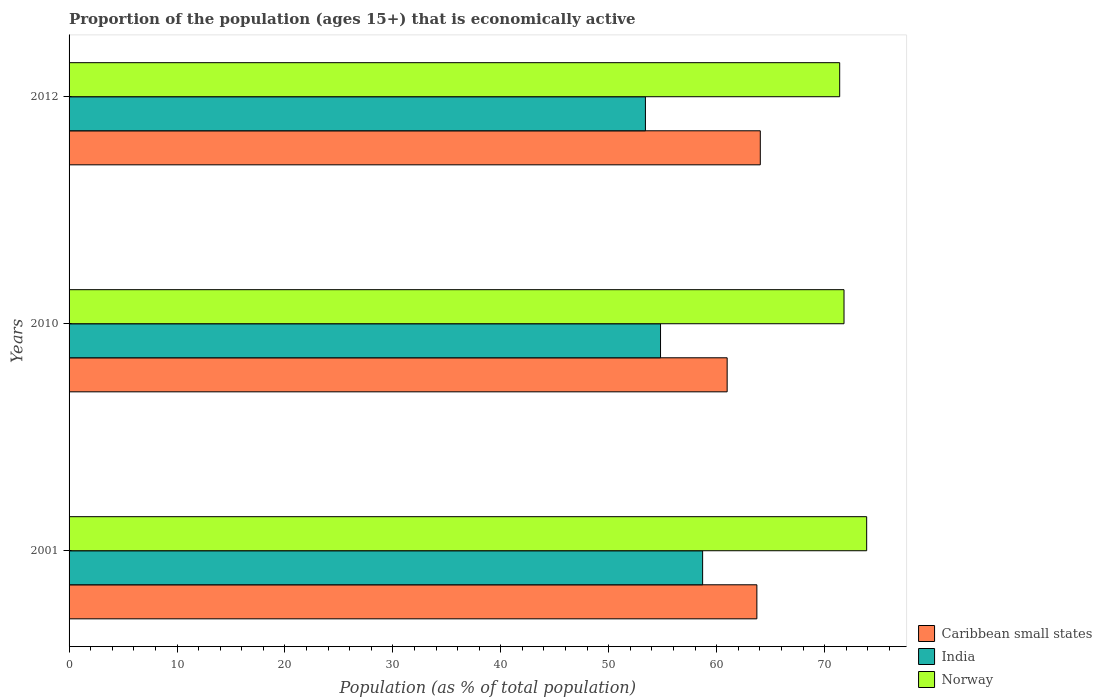Are the number of bars on each tick of the Y-axis equal?
Provide a succinct answer. Yes. How many bars are there on the 1st tick from the top?
Provide a succinct answer. 3. What is the label of the 1st group of bars from the top?
Your response must be concise. 2012. What is the proportion of the population that is economically active in Norway in 2010?
Give a very brief answer. 71.8. Across all years, what is the maximum proportion of the population that is economically active in Caribbean small states?
Your response must be concise. 64.04. Across all years, what is the minimum proportion of the population that is economically active in India?
Provide a short and direct response. 53.4. In which year was the proportion of the population that is economically active in India maximum?
Offer a terse response. 2001. What is the total proportion of the population that is economically active in India in the graph?
Offer a terse response. 166.9. What is the difference between the proportion of the population that is economically active in India in 2001 and that in 2010?
Give a very brief answer. 3.9. What is the difference between the proportion of the population that is economically active in Norway in 2001 and the proportion of the population that is economically active in Caribbean small states in 2012?
Provide a short and direct response. 9.86. What is the average proportion of the population that is economically active in Caribbean small states per year?
Provide a succinct answer. 62.91. In the year 2001, what is the difference between the proportion of the population that is economically active in Caribbean small states and proportion of the population that is economically active in Norway?
Your answer should be very brief. -10.17. In how many years, is the proportion of the population that is economically active in Caribbean small states greater than 48 %?
Provide a short and direct response. 3. What is the ratio of the proportion of the population that is economically active in India in 2001 to that in 2010?
Your answer should be very brief. 1.07. What is the difference between the highest and the second highest proportion of the population that is economically active in Caribbean small states?
Give a very brief answer. 0.32. What is the difference between the highest and the lowest proportion of the population that is economically active in Caribbean small states?
Your answer should be very brief. 3.07. In how many years, is the proportion of the population that is economically active in India greater than the average proportion of the population that is economically active in India taken over all years?
Make the answer very short. 1. Is the sum of the proportion of the population that is economically active in India in 2010 and 2012 greater than the maximum proportion of the population that is economically active in Norway across all years?
Provide a short and direct response. Yes. What does the 1st bar from the top in 2010 represents?
Give a very brief answer. Norway. What does the 1st bar from the bottom in 2001 represents?
Ensure brevity in your answer.  Caribbean small states. Is it the case that in every year, the sum of the proportion of the population that is economically active in Norway and proportion of the population that is economically active in India is greater than the proportion of the population that is economically active in Caribbean small states?
Your answer should be very brief. Yes. How many bars are there?
Your answer should be very brief. 9. Are all the bars in the graph horizontal?
Make the answer very short. Yes. What is the difference between two consecutive major ticks on the X-axis?
Provide a short and direct response. 10. Are the values on the major ticks of X-axis written in scientific E-notation?
Your answer should be very brief. No. Does the graph contain grids?
Provide a short and direct response. No. Where does the legend appear in the graph?
Your answer should be compact. Bottom right. How are the legend labels stacked?
Keep it short and to the point. Vertical. What is the title of the graph?
Your response must be concise. Proportion of the population (ages 15+) that is economically active. What is the label or title of the X-axis?
Offer a terse response. Population (as % of total population). What is the Population (as % of total population) in Caribbean small states in 2001?
Give a very brief answer. 63.73. What is the Population (as % of total population) of India in 2001?
Give a very brief answer. 58.7. What is the Population (as % of total population) in Norway in 2001?
Your answer should be compact. 73.9. What is the Population (as % of total population) of Caribbean small states in 2010?
Offer a very short reply. 60.97. What is the Population (as % of total population) of India in 2010?
Your answer should be very brief. 54.8. What is the Population (as % of total population) of Norway in 2010?
Your response must be concise. 71.8. What is the Population (as % of total population) of Caribbean small states in 2012?
Offer a very short reply. 64.04. What is the Population (as % of total population) of India in 2012?
Offer a terse response. 53.4. What is the Population (as % of total population) in Norway in 2012?
Ensure brevity in your answer.  71.4. Across all years, what is the maximum Population (as % of total population) of Caribbean small states?
Keep it short and to the point. 64.04. Across all years, what is the maximum Population (as % of total population) in India?
Provide a succinct answer. 58.7. Across all years, what is the maximum Population (as % of total population) in Norway?
Ensure brevity in your answer.  73.9. Across all years, what is the minimum Population (as % of total population) in Caribbean small states?
Your answer should be very brief. 60.97. Across all years, what is the minimum Population (as % of total population) of India?
Offer a very short reply. 53.4. Across all years, what is the minimum Population (as % of total population) in Norway?
Offer a very short reply. 71.4. What is the total Population (as % of total population) in Caribbean small states in the graph?
Ensure brevity in your answer.  188.74. What is the total Population (as % of total population) of India in the graph?
Give a very brief answer. 166.9. What is the total Population (as % of total population) in Norway in the graph?
Provide a succinct answer. 217.1. What is the difference between the Population (as % of total population) of Caribbean small states in 2001 and that in 2010?
Provide a short and direct response. 2.75. What is the difference between the Population (as % of total population) in Caribbean small states in 2001 and that in 2012?
Make the answer very short. -0.32. What is the difference between the Population (as % of total population) of India in 2001 and that in 2012?
Provide a short and direct response. 5.3. What is the difference between the Population (as % of total population) of Caribbean small states in 2010 and that in 2012?
Provide a succinct answer. -3.07. What is the difference between the Population (as % of total population) in Norway in 2010 and that in 2012?
Keep it short and to the point. 0.4. What is the difference between the Population (as % of total population) of Caribbean small states in 2001 and the Population (as % of total population) of India in 2010?
Your answer should be compact. 8.93. What is the difference between the Population (as % of total population) in Caribbean small states in 2001 and the Population (as % of total population) in Norway in 2010?
Provide a short and direct response. -8.07. What is the difference between the Population (as % of total population) in India in 2001 and the Population (as % of total population) in Norway in 2010?
Your response must be concise. -13.1. What is the difference between the Population (as % of total population) in Caribbean small states in 2001 and the Population (as % of total population) in India in 2012?
Offer a very short reply. 10.33. What is the difference between the Population (as % of total population) in Caribbean small states in 2001 and the Population (as % of total population) in Norway in 2012?
Provide a short and direct response. -7.67. What is the difference between the Population (as % of total population) of India in 2001 and the Population (as % of total population) of Norway in 2012?
Keep it short and to the point. -12.7. What is the difference between the Population (as % of total population) in Caribbean small states in 2010 and the Population (as % of total population) in India in 2012?
Keep it short and to the point. 7.57. What is the difference between the Population (as % of total population) in Caribbean small states in 2010 and the Population (as % of total population) in Norway in 2012?
Your response must be concise. -10.43. What is the difference between the Population (as % of total population) in India in 2010 and the Population (as % of total population) in Norway in 2012?
Offer a terse response. -16.6. What is the average Population (as % of total population) in Caribbean small states per year?
Your response must be concise. 62.91. What is the average Population (as % of total population) of India per year?
Offer a very short reply. 55.63. What is the average Population (as % of total population) of Norway per year?
Offer a terse response. 72.37. In the year 2001, what is the difference between the Population (as % of total population) of Caribbean small states and Population (as % of total population) of India?
Ensure brevity in your answer.  5.03. In the year 2001, what is the difference between the Population (as % of total population) in Caribbean small states and Population (as % of total population) in Norway?
Your answer should be compact. -10.17. In the year 2001, what is the difference between the Population (as % of total population) of India and Population (as % of total population) of Norway?
Your response must be concise. -15.2. In the year 2010, what is the difference between the Population (as % of total population) in Caribbean small states and Population (as % of total population) in India?
Ensure brevity in your answer.  6.17. In the year 2010, what is the difference between the Population (as % of total population) of Caribbean small states and Population (as % of total population) of Norway?
Keep it short and to the point. -10.83. In the year 2012, what is the difference between the Population (as % of total population) in Caribbean small states and Population (as % of total population) in India?
Ensure brevity in your answer.  10.64. In the year 2012, what is the difference between the Population (as % of total population) of Caribbean small states and Population (as % of total population) of Norway?
Provide a succinct answer. -7.36. In the year 2012, what is the difference between the Population (as % of total population) in India and Population (as % of total population) in Norway?
Offer a terse response. -18. What is the ratio of the Population (as % of total population) in Caribbean small states in 2001 to that in 2010?
Your answer should be very brief. 1.05. What is the ratio of the Population (as % of total population) of India in 2001 to that in 2010?
Provide a succinct answer. 1.07. What is the ratio of the Population (as % of total population) of Norway in 2001 to that in 2010?
Make the answer very short. 1.03. What is the ratio of the Population (as % of total population) of India in 2001 to that in 2012?
Offer a very short reply. 1.1. What is the ratio of the Population (as % of total population) in Norway in 2001 to that in 2012?
Provide a succinct answer. 1.03. What is the ratio of the Population (as % of total population) of Caribbean small states in 2010 to that in 2012?
Make the answer very short. 0.95. What is the ratio of the Population (as % of total population) of India in 2010 to that in 2012?
Your response must be concise. 1.03. What is the ratio of the Population (as % of total population) of Norway in 2010 to that in 2012?
Your response must be concise. 1.01. What is the difference between the highest and the second highest Population (as % of total population) of Caribbean small states?
Your response must be concise. 0.32. What is the difference between the highest and the second highest Population (as % of total population) of India?
Keep it short and to the point. 3.9. What is the difference between the highest and the second highest Population (as % of total population) of Norway?
Keep it short and to the point. 2.1. What is the difference between the highest and the lowest Population (as % of total population) of Caribbean small states?
Your response must be concise. 3.07. 